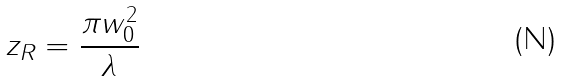<formula> <loc_0><loc_0><loc_500><loc_500>z _ { R } = { \frac { \pi w _ { 0 } ^ { 2 } } { \lambda } }</formula> 